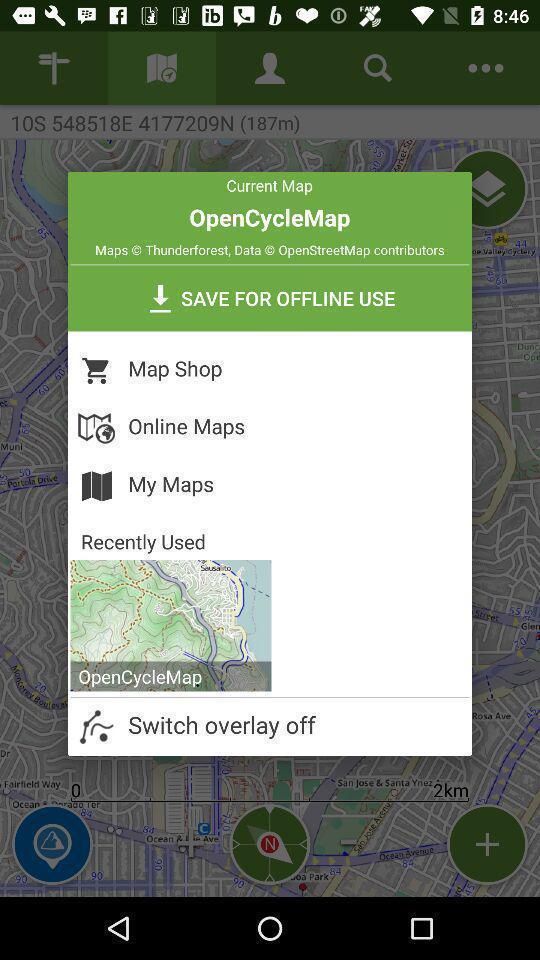Give me a summary of this screen capture. Pop-up with options in a local adventures finder app. 